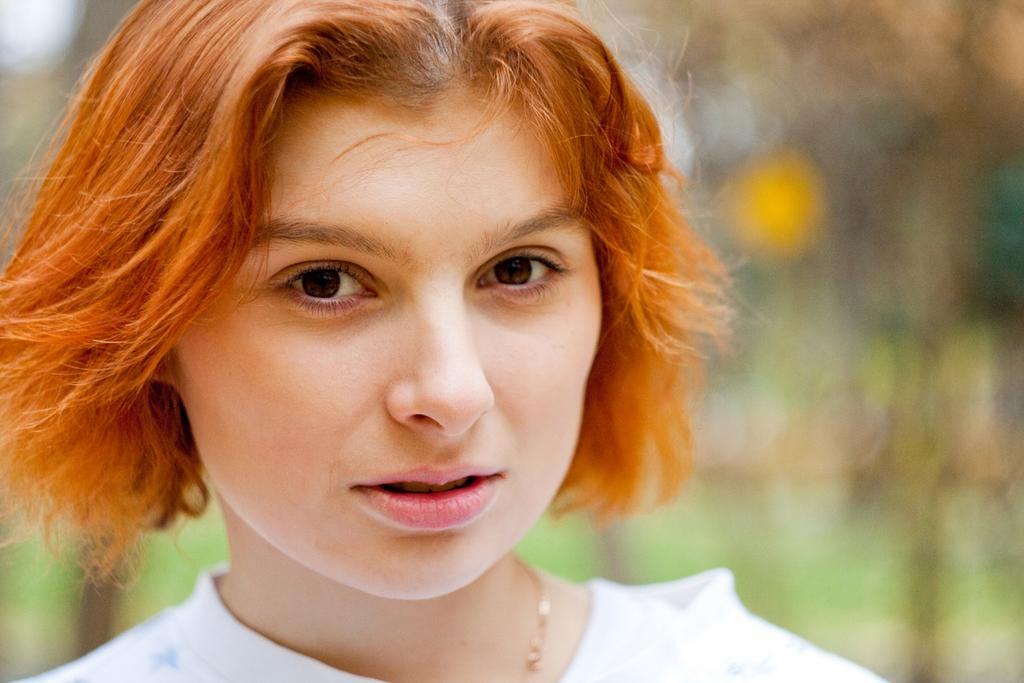What is the main subject of the image? There is a lady in the center of the image. Can you describe the background of the image? The background of the image is blurry. What type of lace is the lady using for her journey in the image? There is no mention of lace or a journey in the image; it only features a lady in the center and a blurry background. 